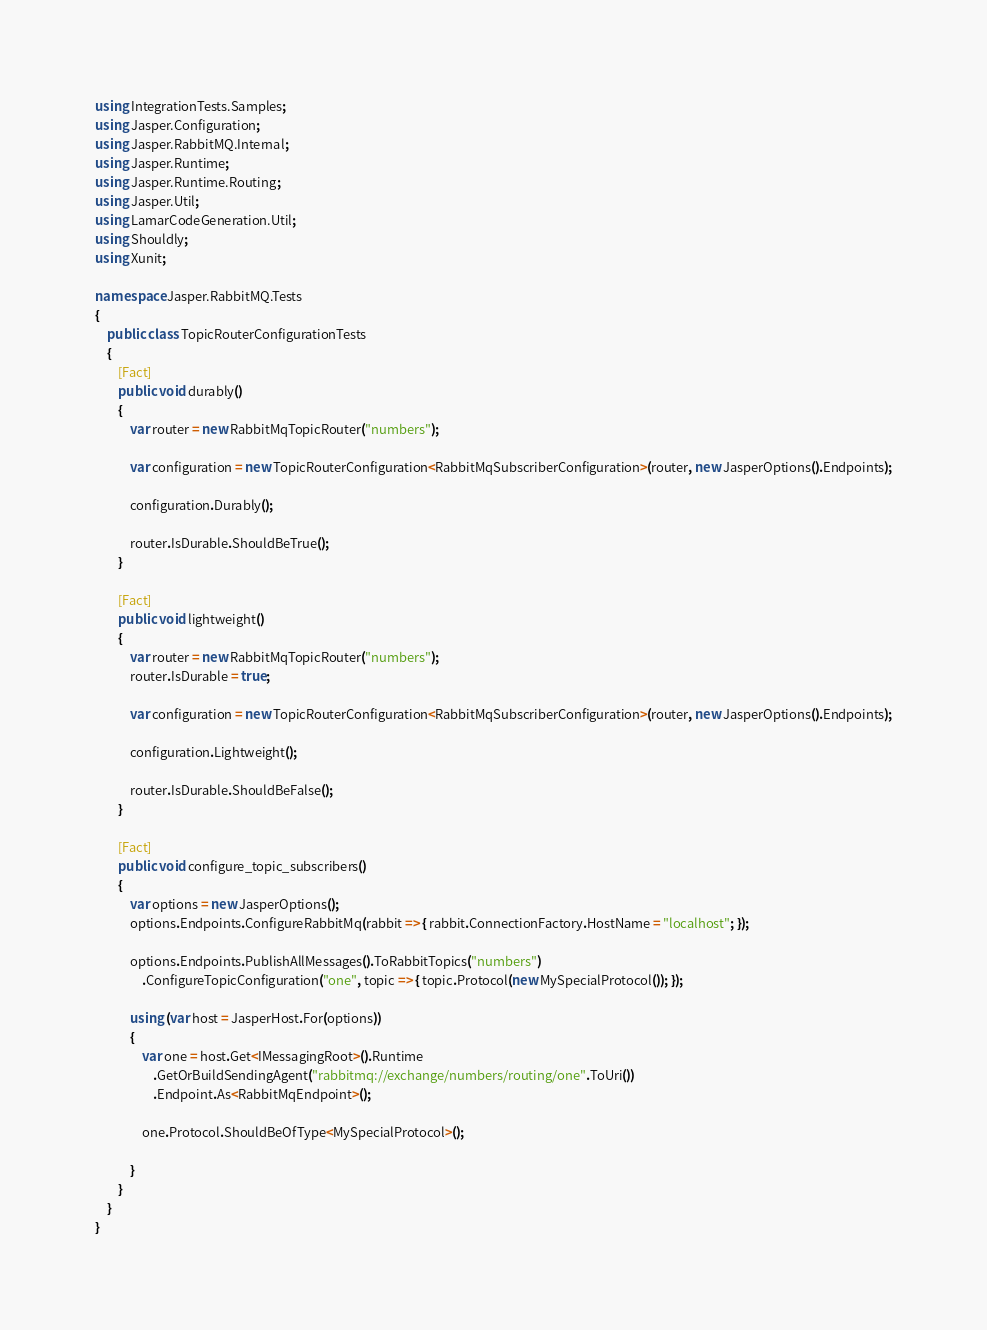Convert code to text. <code><loc_0><loc_0><loc_500><loc_500><_C#_>using IntegrationTests.Samples;
using Jasper.Configuration;
using Jasper.RabbitMQ.Internal;
using Jasper.Runtime;
using Jasper.Runtime.Routing;
using Jasper.Util;
using LamarCodeGeneration.Util;
using Shouldly;
using Xunit;

namespace Jasper.RabbitMQ.Tests
{
    public class TopicRouterConfigurationTests
    {
        [Fact]
        public void durably()
        {
            var router = new RabbitMqTopicRouter("numbers");

            var configuration = new TopicRouterConfiguration<RabbitMqSubscriberConfiguration>(router, new JasperOptions().Endpoints);

            configuration.Durably();

            router.IsDurable.ShouldBeTrue();
        }

        [Fact]
        public void lightweight()
        {
            var router = new RabbitMqTopicRouter("numbers");
            router.IsDurable = true;

            var configuration = new TopicRouterConfiguration<RabbitMqSubscriberConfiguration>(router, new JasperOptions().Endpoints);

            configuration.Lightweight();

            router.IsDurable.ShouldBeFalse();
        }

        [Fact]
        public void configure_topic_subscribers()
        {
            var options = new JasperOptions();
            options.Endpoints.ConfigureRabbitMq(rabbit => { rabbit.ConnectionFactory.HostName = "localhost"; });

            options.Endpoints.PublishAllMessages().ToRabbitTopics("numbers")
                .ConfigureTopicConfiguration("one", topic => { topic.Protocol(new MySpecialProtocol()); });

            using (var host = JasperHost.For(options))
            {
                var one = host.Get<IMessagingRoot>().Runtime
                    .GetOrBuildSendingAgent("rabbitmq://exchange/numbers/routing/one".ToUri())
                    .Endpoint.As<RabbitMqEndpoint>();

                one.Protocol.ShouldBeOfType<MySpecialProtocol>();

            }
        }
    }
}
</code> 